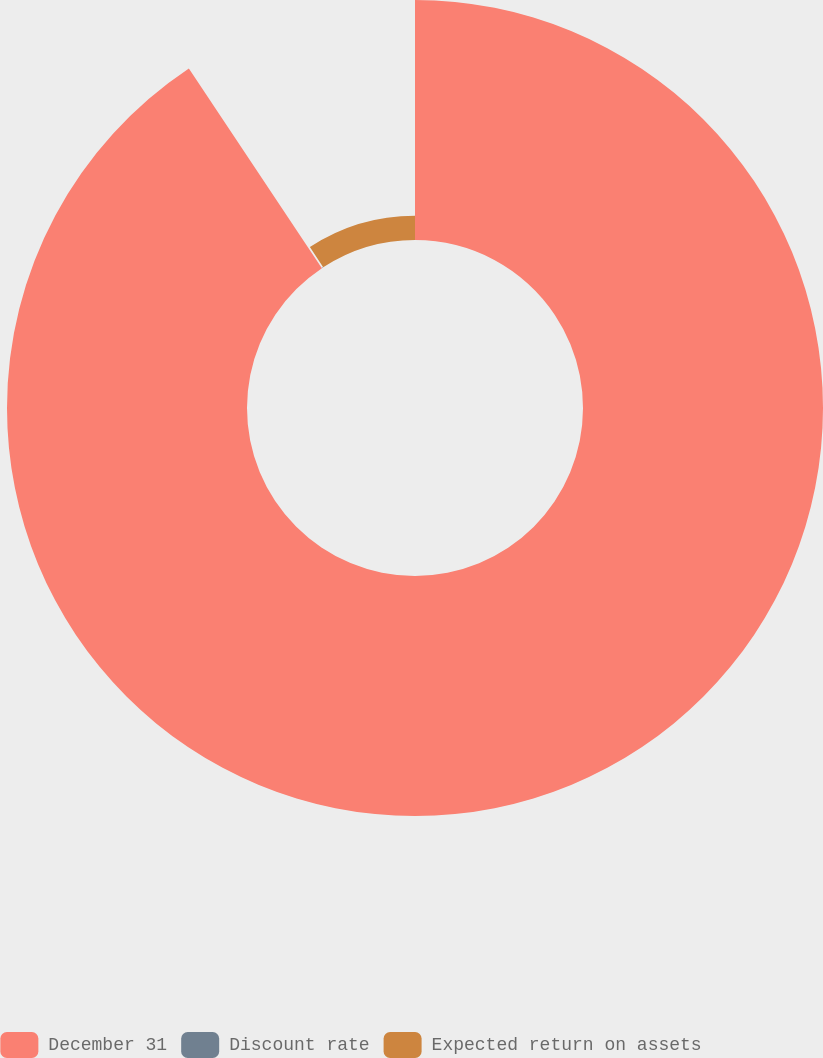Convert chart. <chart><loc_0><loc_0><loc_500><loc_500><pie_chart><fcel>December 31<fcel>Discount rate<fcel>Expected return on assets<nl><fcel>90.65%<fcel>0.15%<fcel>9.2%<nl></chart> 